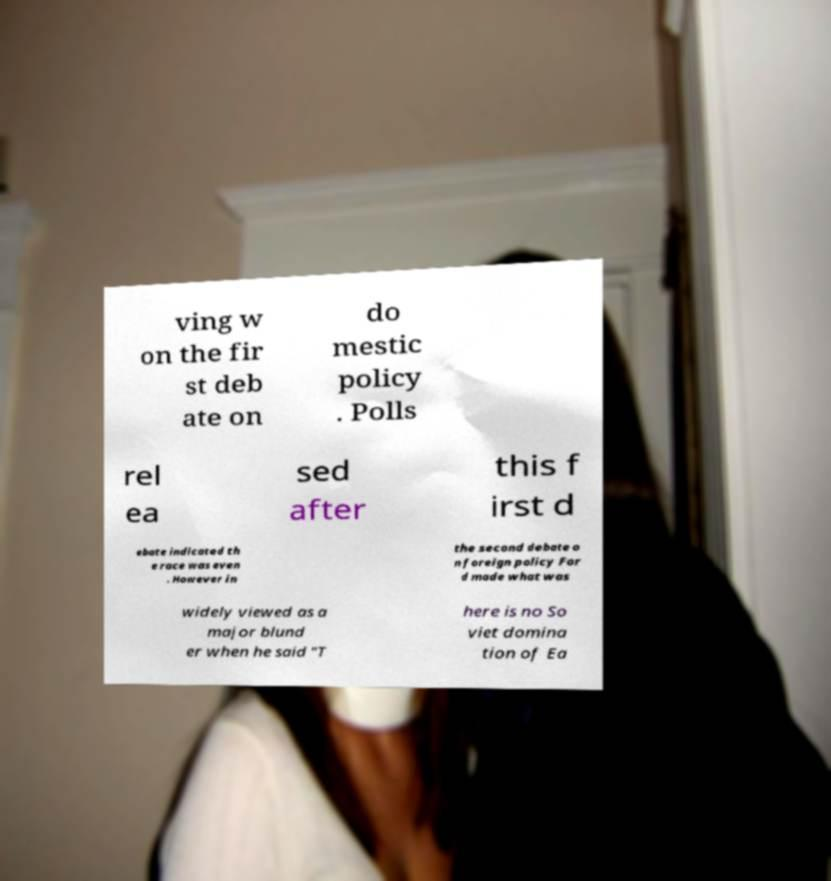Can you accurately transcribe the text from the provided image for me? ving w on the fir st deb ate on do mestic policy . Polls rel ea sed after this f irst d ebate indicated th e race was even . However in the second debate o n foreign policy For d made what was widely viewed as a major blund er when he said "T here is no So viet domina tion of Ea 